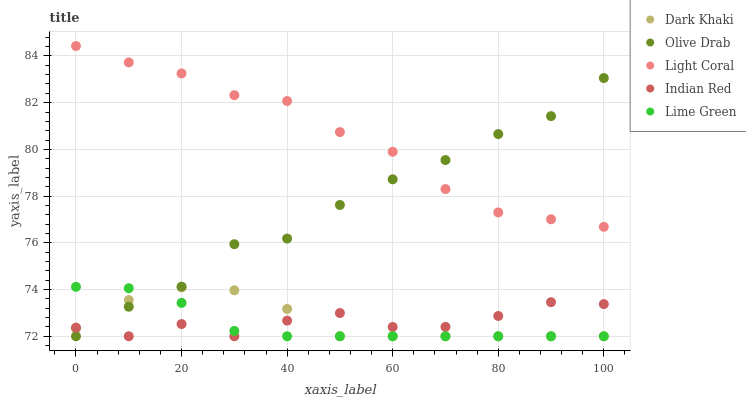Does Lime Green have the minimum area under the curve?
Answer yes or no. Yes. Does Light Coral have the maximum area under the curve?
Answer yes or no. Yes. Does Light Coral have the minimum area under the curve?
Answer yes or no. No. Does Lime Green have the maximum area under the curve?
Answer yes or no. No. Is Lime Green the smoothest?
Answer yes or no. Yes. Is Indian Red the roughest?
Answer yes or no. Yes. Is Light Coral the smoothest?
Answer yes or no. No. Is Light Coral the roughest?
Answer yes or no. No. Does Dark Khaki have the lowest value?
Answer yes or no. Yes. Does Light Coral have the lowest value?
Answer yes or no. No. Does Light Coral have the highest value?
Answer yes or no. Yes. Does Lime Green have the highest value?
Answer yes or no. No. Is Indian Red less than Light Coral?
Answer yes or no. Yes. Is Light Coral greater than Indian Red?
Answer yes or no. Yes. Does Dark Khaki intersect Olive Drab?
Answer yes or no. Yes. Is Dark Khaki less than Olive Drab?
Answer yes or no. No. Is Dark Khaki greater than Olive Drab?
Answer yes or no. No. Does Indian Red intersect Light Coral?
Answer yes or no. No. 